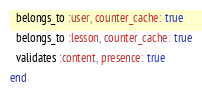<code> <loc_0><loc_0><loc_500><loc_500><_Ruby_>  belongs_to :user, counter_cache: true
  belongs_to :lesson, counter_cache: true
  validates :content, presence: true
end
</code> 